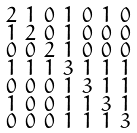<formula> <loc_0><loc_0><loc_500><loc_500>\begin{smallmatrix} 2 & 1 & 0 & 1 & 0 & 1 & 0 \\ 1 & 2 & 0 & 1 & 0 & 0 & 0 \\ 0 & 0 & 2 & 1 & 0 & 0 & 0 \\ 1 & 1 & 1 & 3 & 1 & 1 & 1 \\ 0 & 0 & 0 & 1 & 3 & 1 & 1 \\ 1 & 0 & 0 & 1 & 1 & 3 & 1 \\ 0 & 0 & 0 & 1 & 1 & 1 & 3 \end{smallmatrix}</formula> 